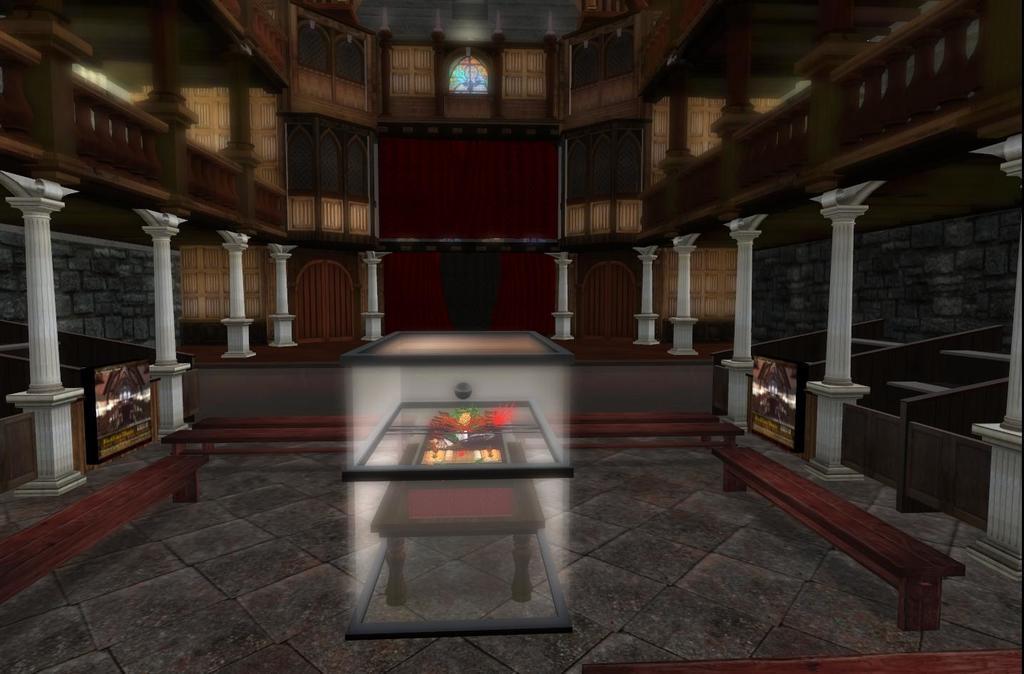Please provide a concise description of this image. This looks like an animated image. These are the pillars. I can see the wooden benches, which are placed on the floor. This looks like a photo frame. I can see a table, which is covered with a glass box. At the top of the image, that looks like a glass door with a painting on it. I think this is a stage. 